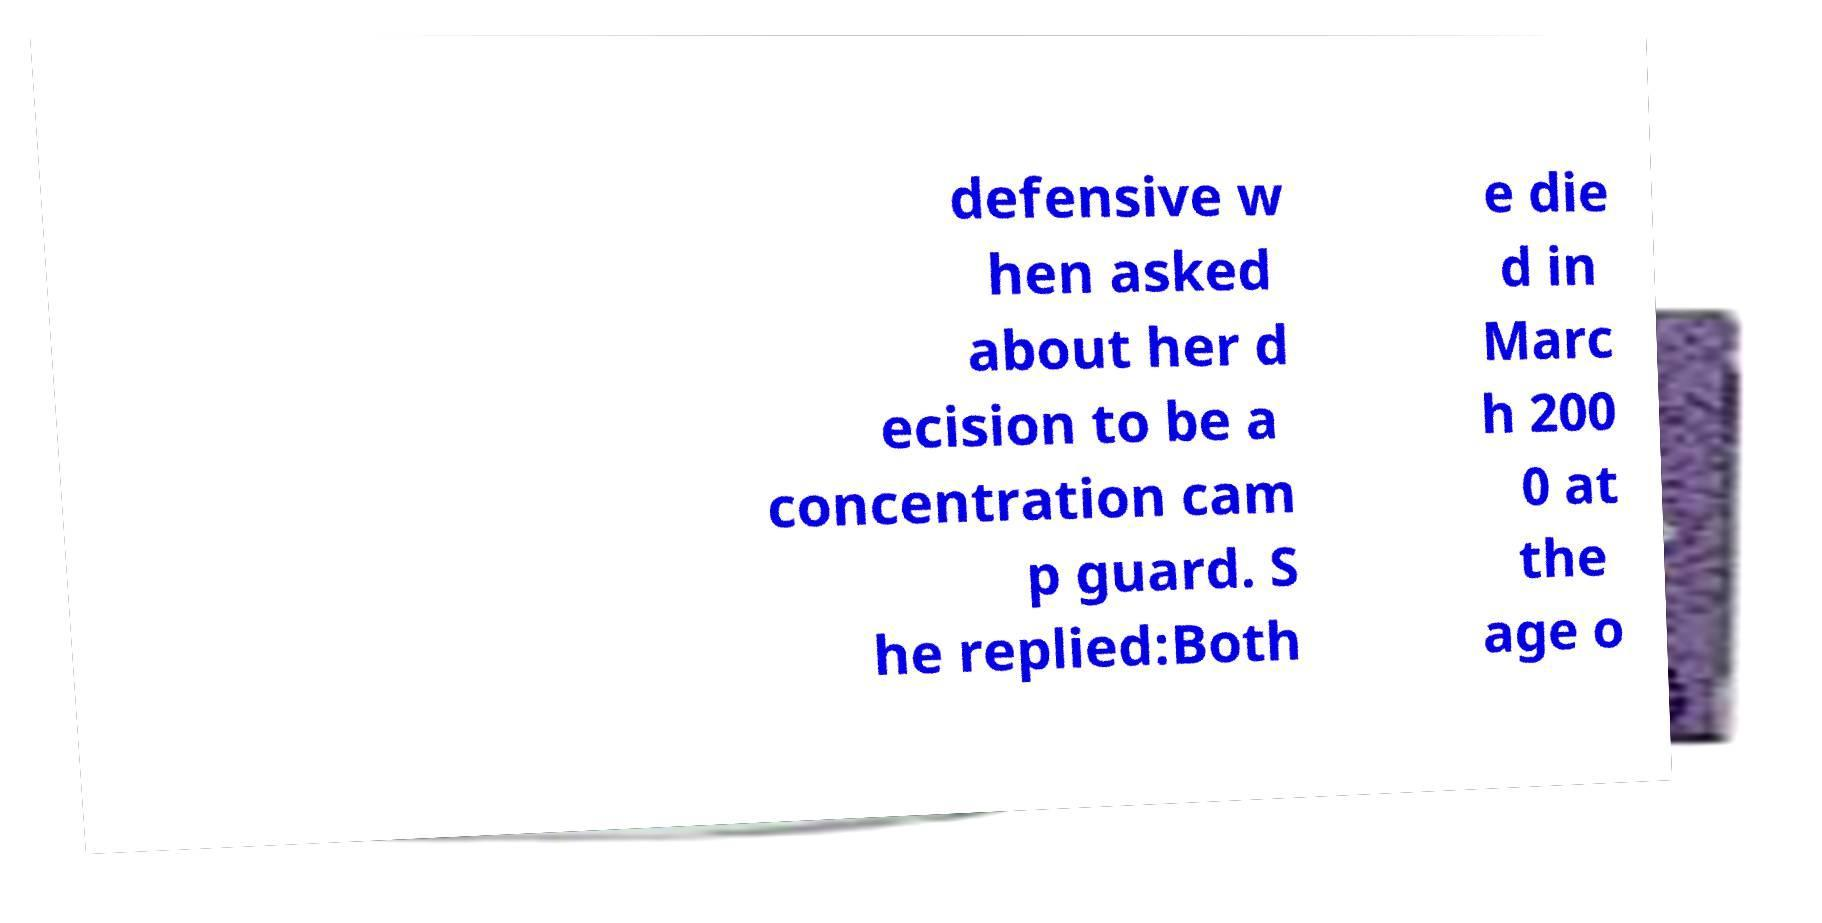I need the written content from this picture converted into text. Can you do that? defensive w hen asked about her d ecision to be a concentration cam p guard. S he replied:Both e die d in Marc h 200 0 at the age o 